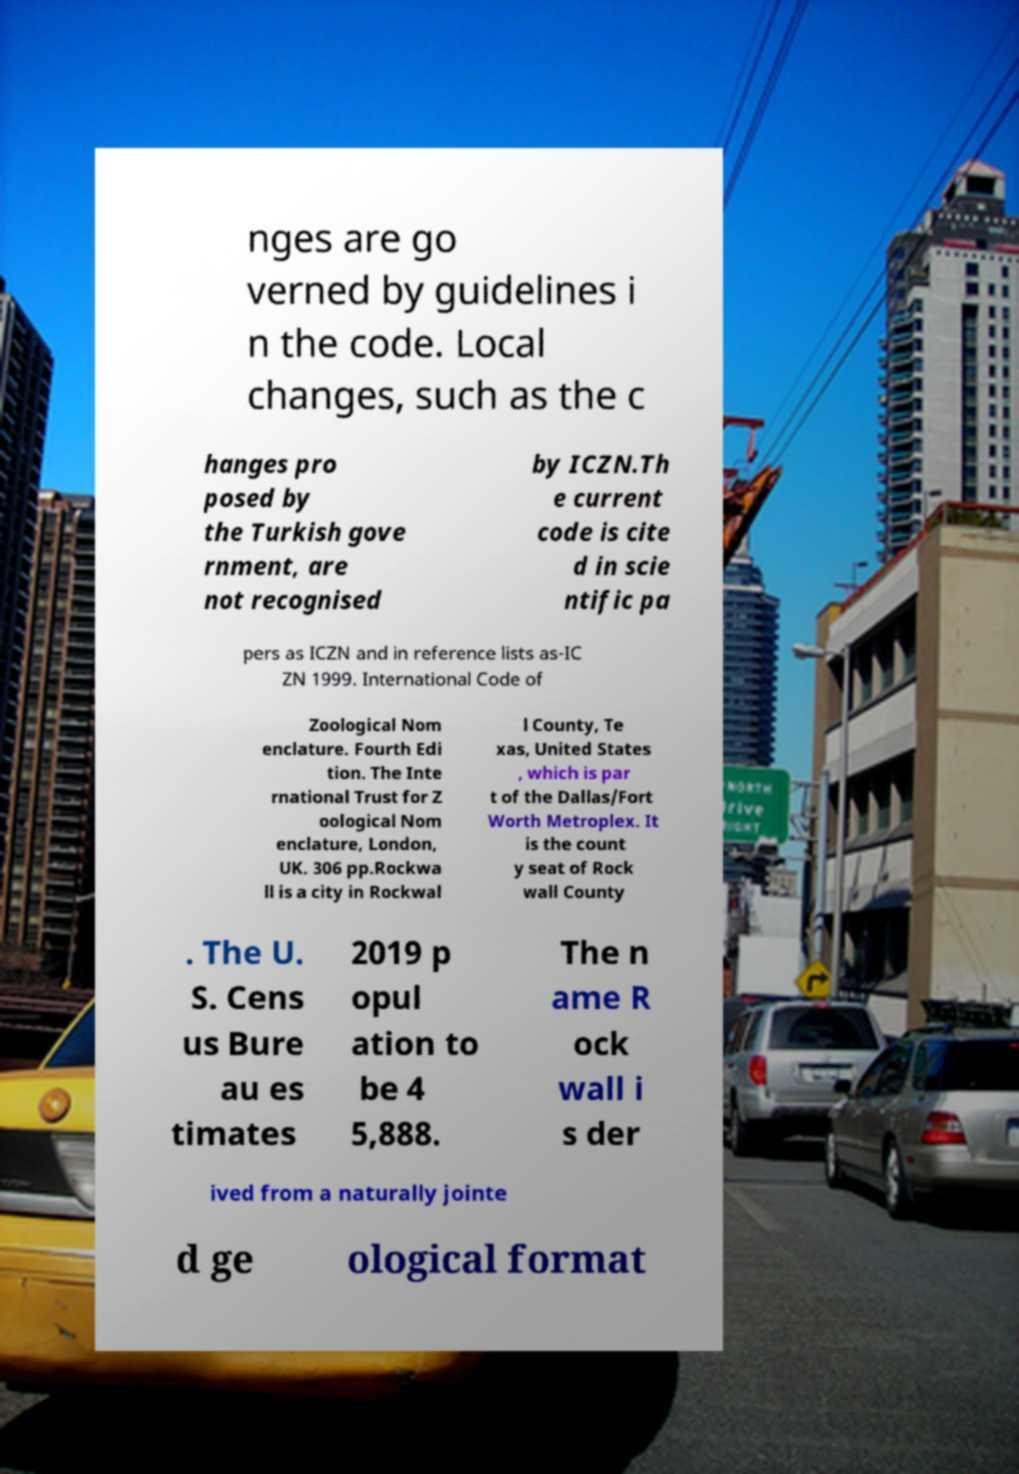Could you assist in decoding the text presented in this image and type it out clearly? nges are go verned by guidelines i n the code. Local changes, such as the c hanges pro posed by the Turkish gove rnment, are not recognised by ICZN.Th e current code is cite d in scie ntific pa pers as ICZN and in reference lists as-IC ZN 1999. International Code of Zoological Nom enclature. Fourth Edi tion. The Inte rnational Trust for Z oological Nom enclature, London, UK. 306 pp.Rockwa ll is a city in Rockwal l County, Te xas, United States , which is par t of the Dallas/Fort Worth Metroplex. It is the count y seat of Rock wall County . The U. S. Cens us Bure au es timates 2019 p opul ation to be 4 5,888. The n ame R ock wall i s der ived from a naturally jointe d ge ological format 